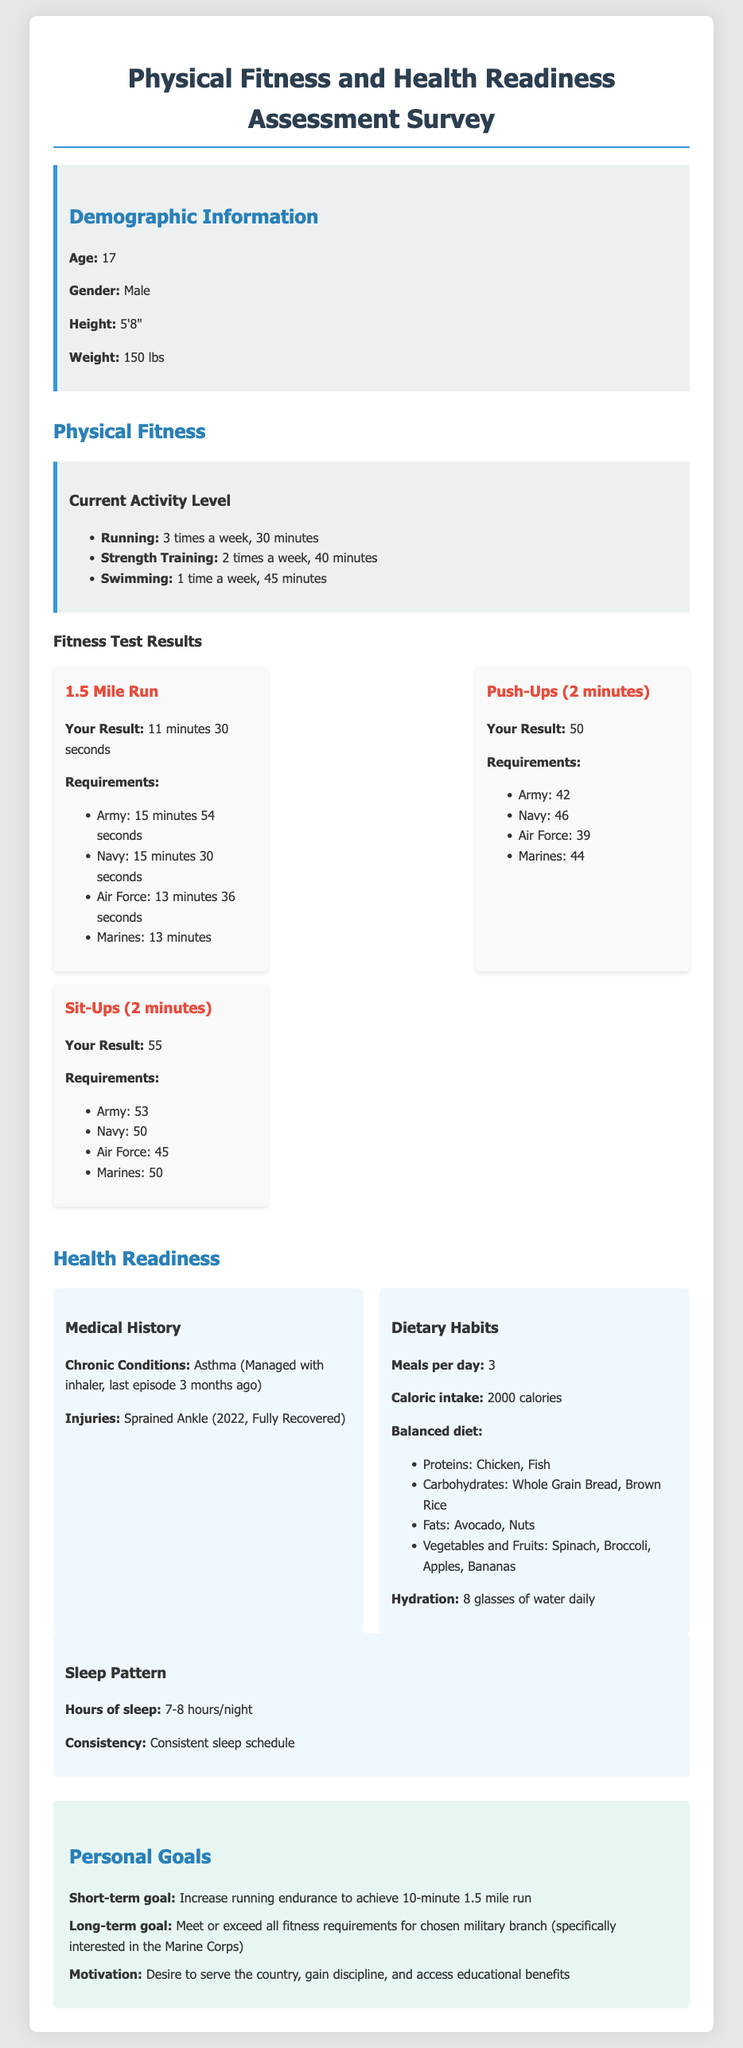What is the age of the participant? The participant's age is explicitly mentioned in the document as 17.
Answer: 17 What is the participant's weight? The weight of the participant is stated as 150 lbs in the demographic section.
Answer: 150 lbs How many push-ups did the participant perform? The result for push-ups is listed as 50, according to the fitness test results.
Answer: 50 What is the participant's short-term fitness goal? The short-term goal specifically mentioned is to increase running endurance to achieve 10-minute 1.5 mile run.
Answer: 10-minute 1.5 mile run Which military branch is the participant specifically interested in? The document indicates that the participant has a specific interest in joining the Marine Corps.
Answer: Marine Corps How many meals does the participant consume per day? The document states that the participant consumes 3 meals per day.
Answer: 3 What is the participant's hydration habit? The number of glasses of water the participant drinks daily is mentioned as 8.
Answer: 8 glasses What is the required time for the 1.5 mile run for the Marines? The requirement for the Marines' 1.5 mile run is given as 13 minutes.
Answer: 13 minutes What chronic condition does the participant manage? The document mentions that the participant has asthma, which is managed with an inhaler.
Answer: Asthma 